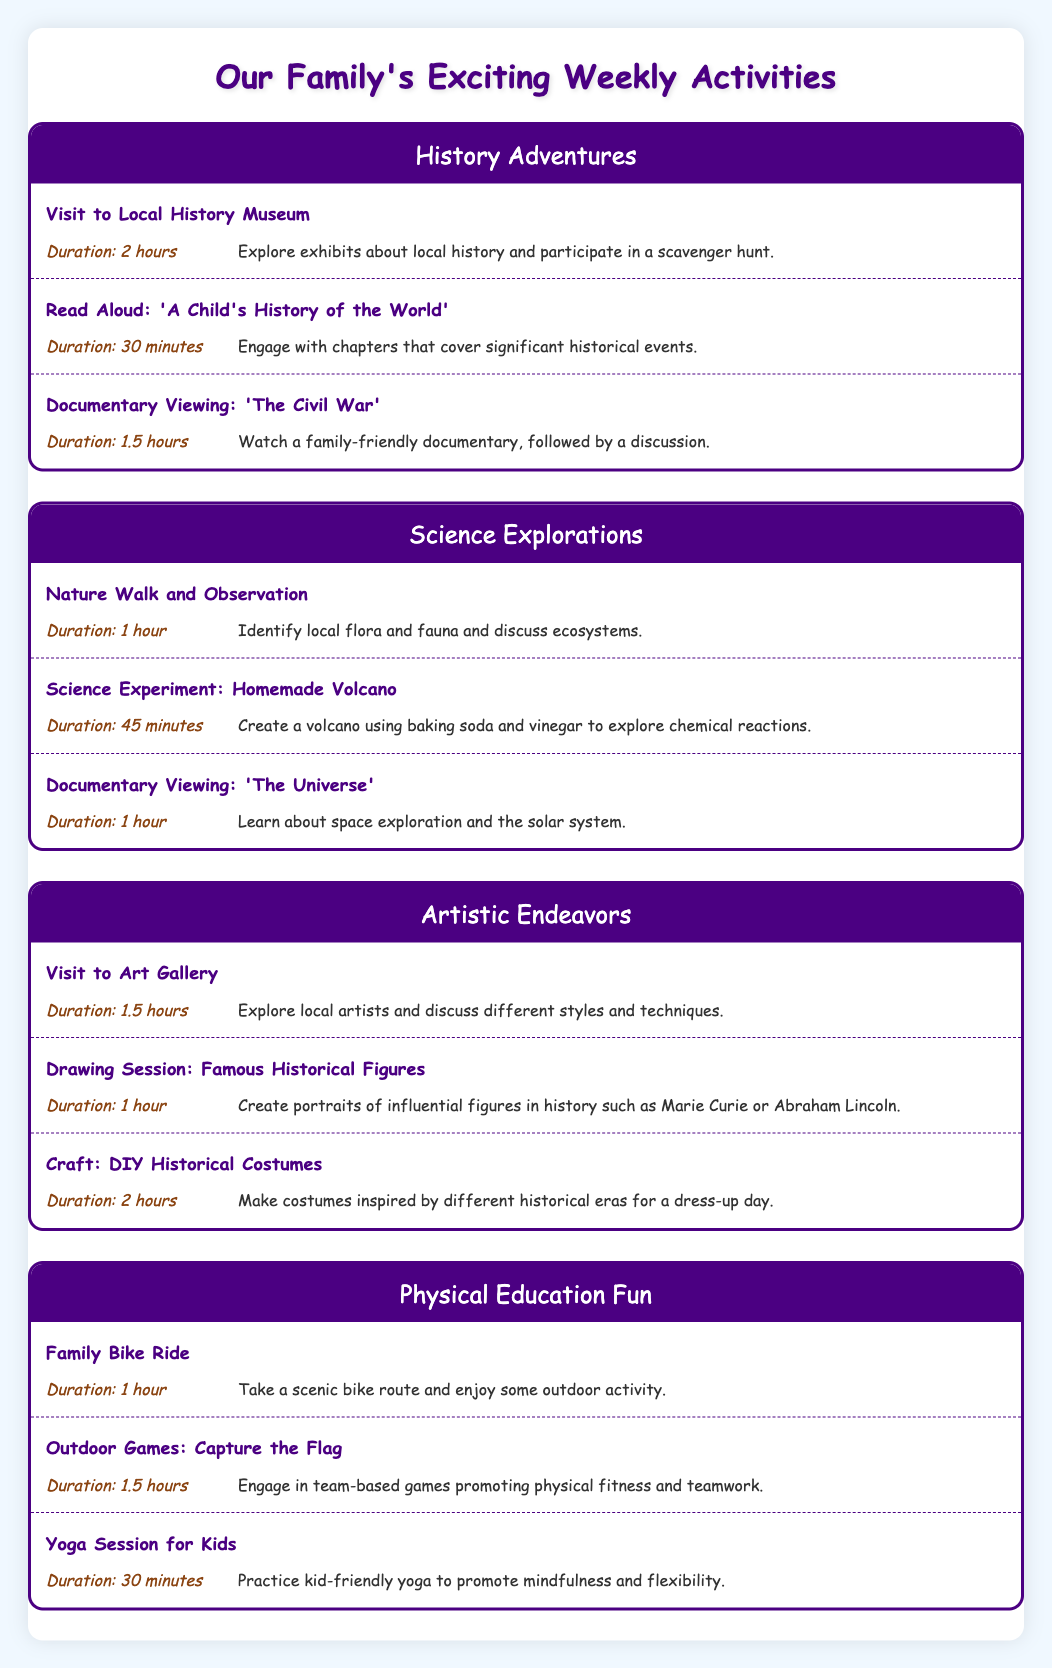What is the duration of the activity "Read Aloud: 'A Child's History of the World'"? The duration is directly listed in the table under the "History Adventures" section. It states that the duration is 30 minutes.
Answer: 30 minutes How many activities are listed under the Science category? By counting the activities listed in the "Science Explorations" section, I see there are three activities: "Nature Walk and Observation," "Science Experiment: Homemade Volcano," and "Documentary Viewing: 'The Universe'."
Answer: 3 activities What is the total duration of the Physical Education activities? The durations of the Physical Education activities are as follows: 1 hour (Family Bike Ride) + 1.5 hours (Outdoor Games: Capture the Flag) + 30 minutes (Yoga Session for Kids). First, convert the durations to a consistent measurement: 1 hour = 60 minutes, so 1.5 hours = 90 minutes. Then add: 60 + 90 + 30 = 180 minutes, which is 3 hours.
Answer: 3 hours Is there an art activity that has a duration of 2 hours? Looking through the "Artistic Endeavors" section, the activity "Craft: DIY Historical Costumes" is listed with a duration of 2 hours. This confirms that such an activity exists under the Arts category.
Answer: Yes What is the average duration of activities in the History category? The durations of the History activities are: 2 hours (120 minutes) + 30 minutes + 1.5 hours (90 minutes). First, sum these durations: 120 + 30 + 90 = 240 minutes. There are three activities, so to find the average, divide by the number of activities: 240 minutes / 3 = 80 minutes.
Answer: 80 minutes 